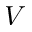<formula> <loc_0><loc_0><loc_500><loc_500>V</formula> 